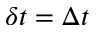Convert formula to latex. <formula><loc_0><loc_0><loc_500><loc_500>\delta t = \Delta t</formula> 